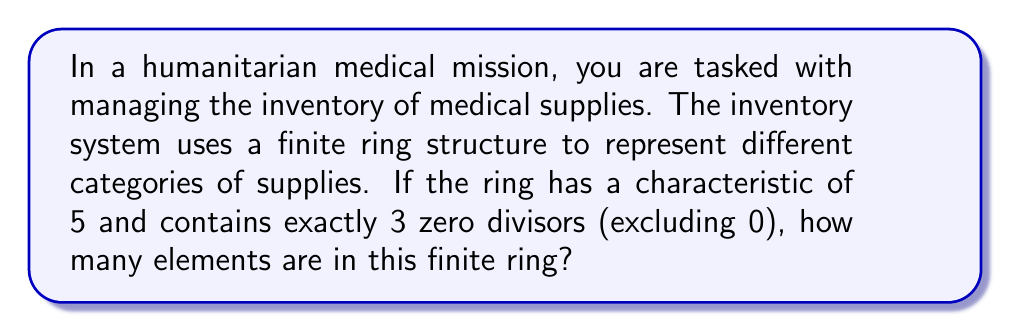Can you solve this math problem? To solve this problem, we need to use properties of finite rings and zero divisors:

1) In a finite ring of characteristic 5, the number of elements is always a power of 5. Let's denote the number of elements as $5^n$ where $n$ is a positive integer.

2) In a finite ring, every element is either a unit (has a multiplicative inverse) or a zero divisor.

3) The number of zero divisors in a finite ring with $5^n$ elements is always of the form $5^k - 1$ where $1 \leq k \leq n$.

4) Given that there are exactly 3 zero divisors (excluding 0), we can set up the equation:

   $5^k - 1 = 3$

5) Solving this equation:
   $5^k = 4$
   $k = 1$ (since $5^1 = 5$ is the only power of 5 that gives a result close to 4)

6) Since $k = 1$, we know that $n = 1$ as well (because $k$ cannot be greater than $n$).

7) Therefore, the number of elements in the ring is $5^n = 5^1 = 5$.

We can verify:
- The ring has 5 elements: $\{0, 1, 2, 3, 4\}$ (under modulo 5 arithmetic)
- The zero divisors are 2, 3, and 4 (excluding 0)
- 1 is the only unit (besides 0)

This structure accurately represents a simple inventory system with 5 categories of medical supplies.
Answer: The finite ring representing the medical supply inventory contains 5 elements. 